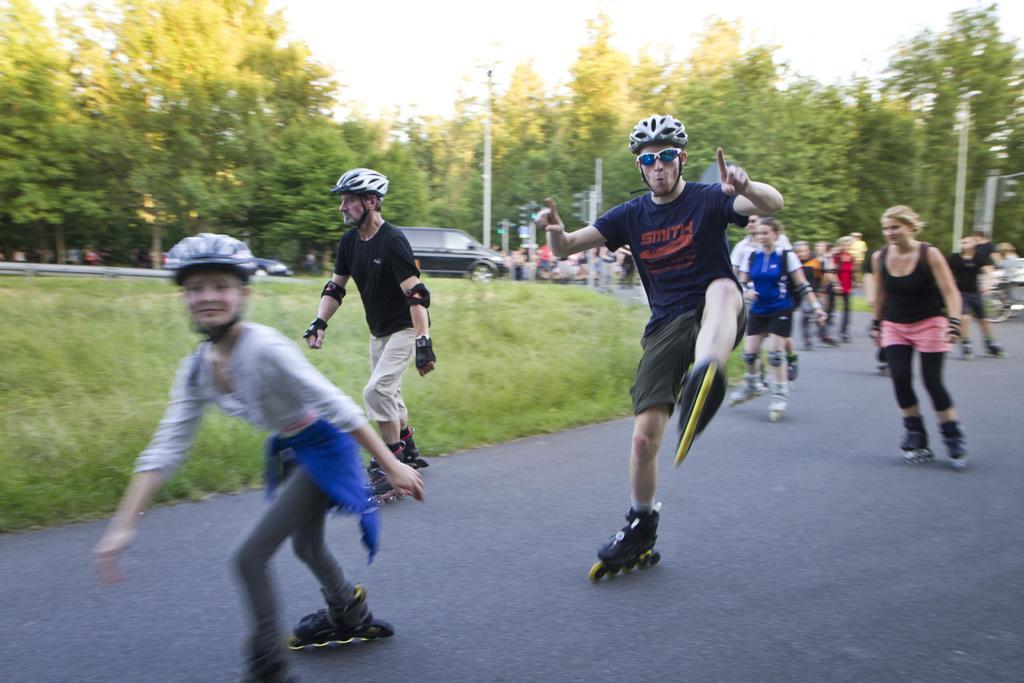Could you give a brief overview of what you see in this image? In this picture I can see the road, on which there are number of people who are wearing roller skates and I see helmets on few of them. In the middle of this picture I see the grass. In the background I see the trees, few cars, poles and the sky. 